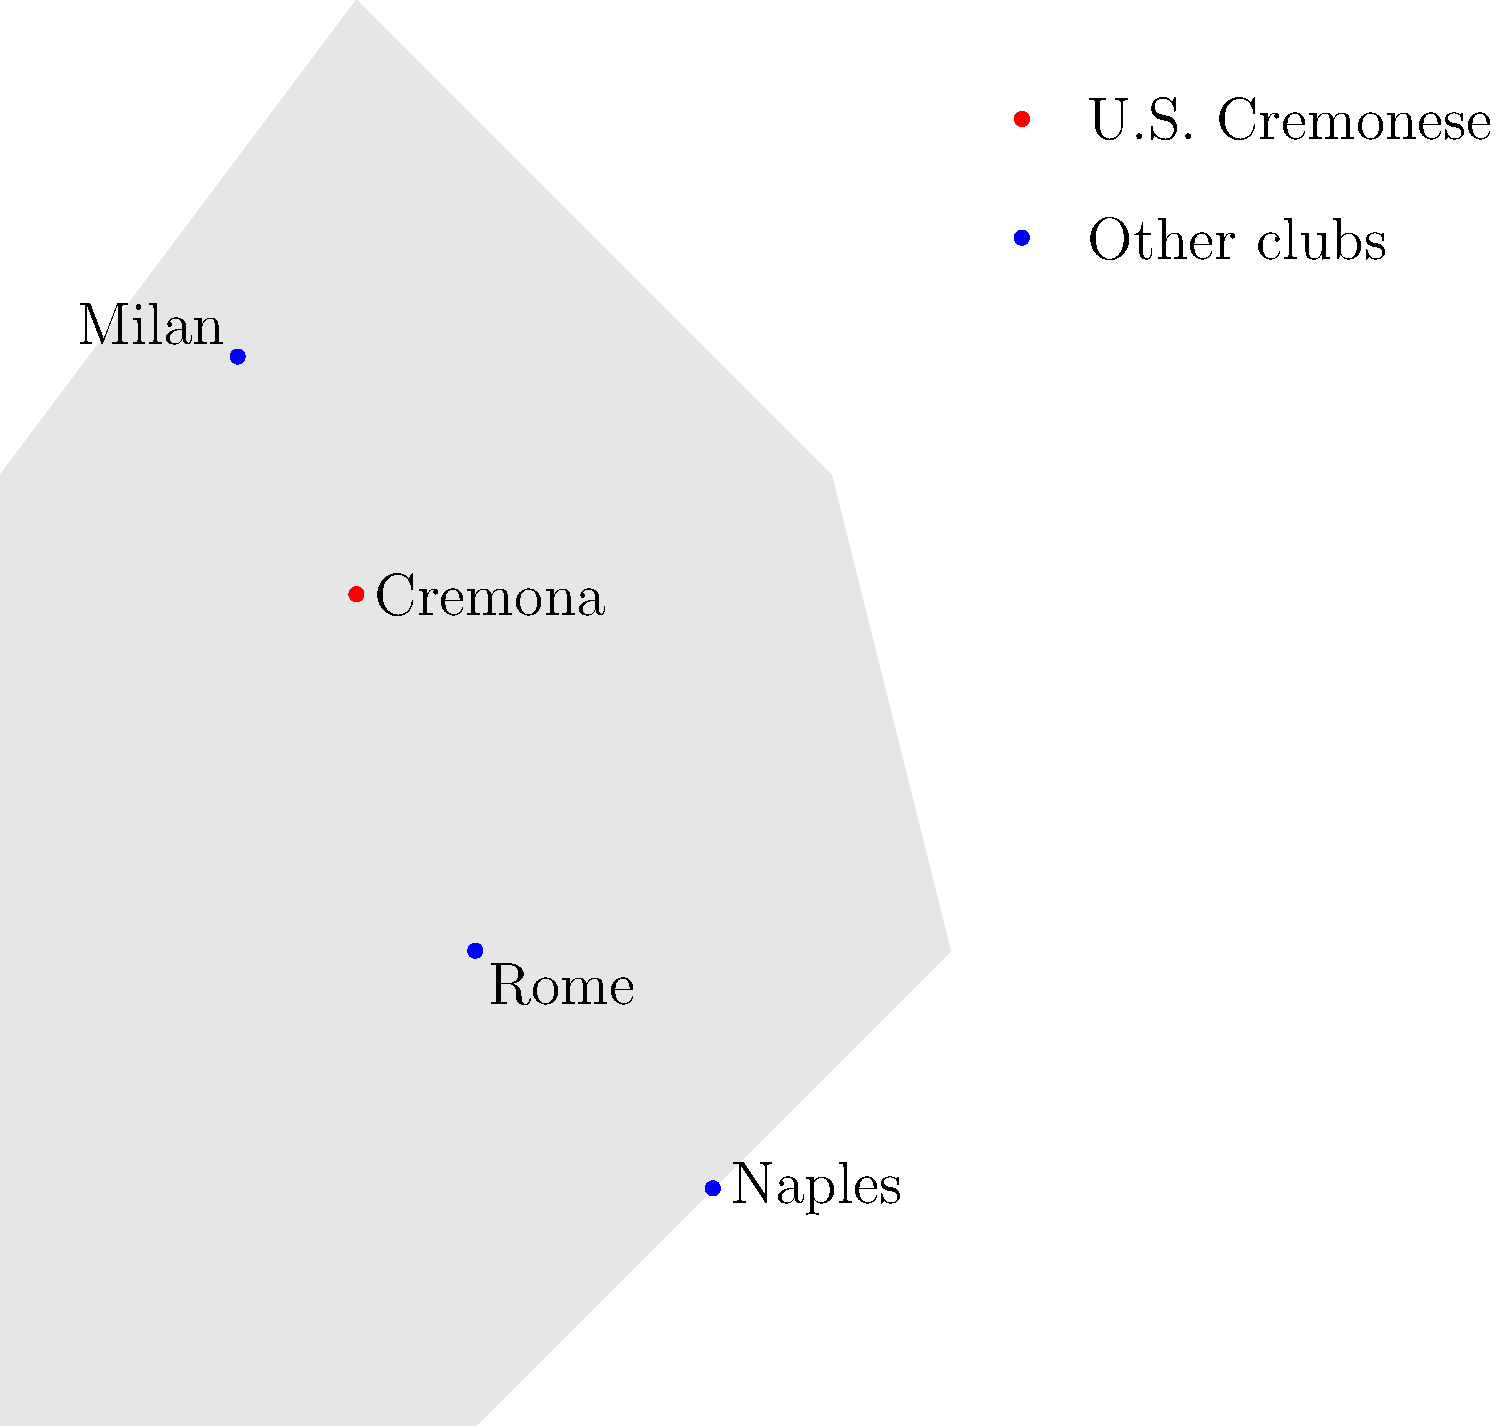On the map of Italian football clubs, which city is highlighted in red, representing the location of U.S. Cremonese? To identify the location of U.S. Cremonese on the map:

1. Observe the map of Italy with four cities marked.
2. Note the legend indicating that the red dot represents U.S. Cremonese.
3. Scan the map for the red dot.
4. Identify that the red dot is located in the northern part of Italy.
5. Read the label next to the red dot, which clearly states "Cremona".
6. Confirm that Cremona is indeed the home city of U.S. Cremonese.

Therefore, the city highlighted in red, representing the location of U.S. Cremonese, is Cremona.
Answer: Cremona 